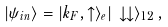<formula> <loc_0><loc_0><loc_500><loc_500>| \psi _ { i n } \rangle = | k _ { F } , \uparrow \rangle _ { e } | \, \downarrow \downarrow \rangle _ { 1 2 } \, ,</formula> 